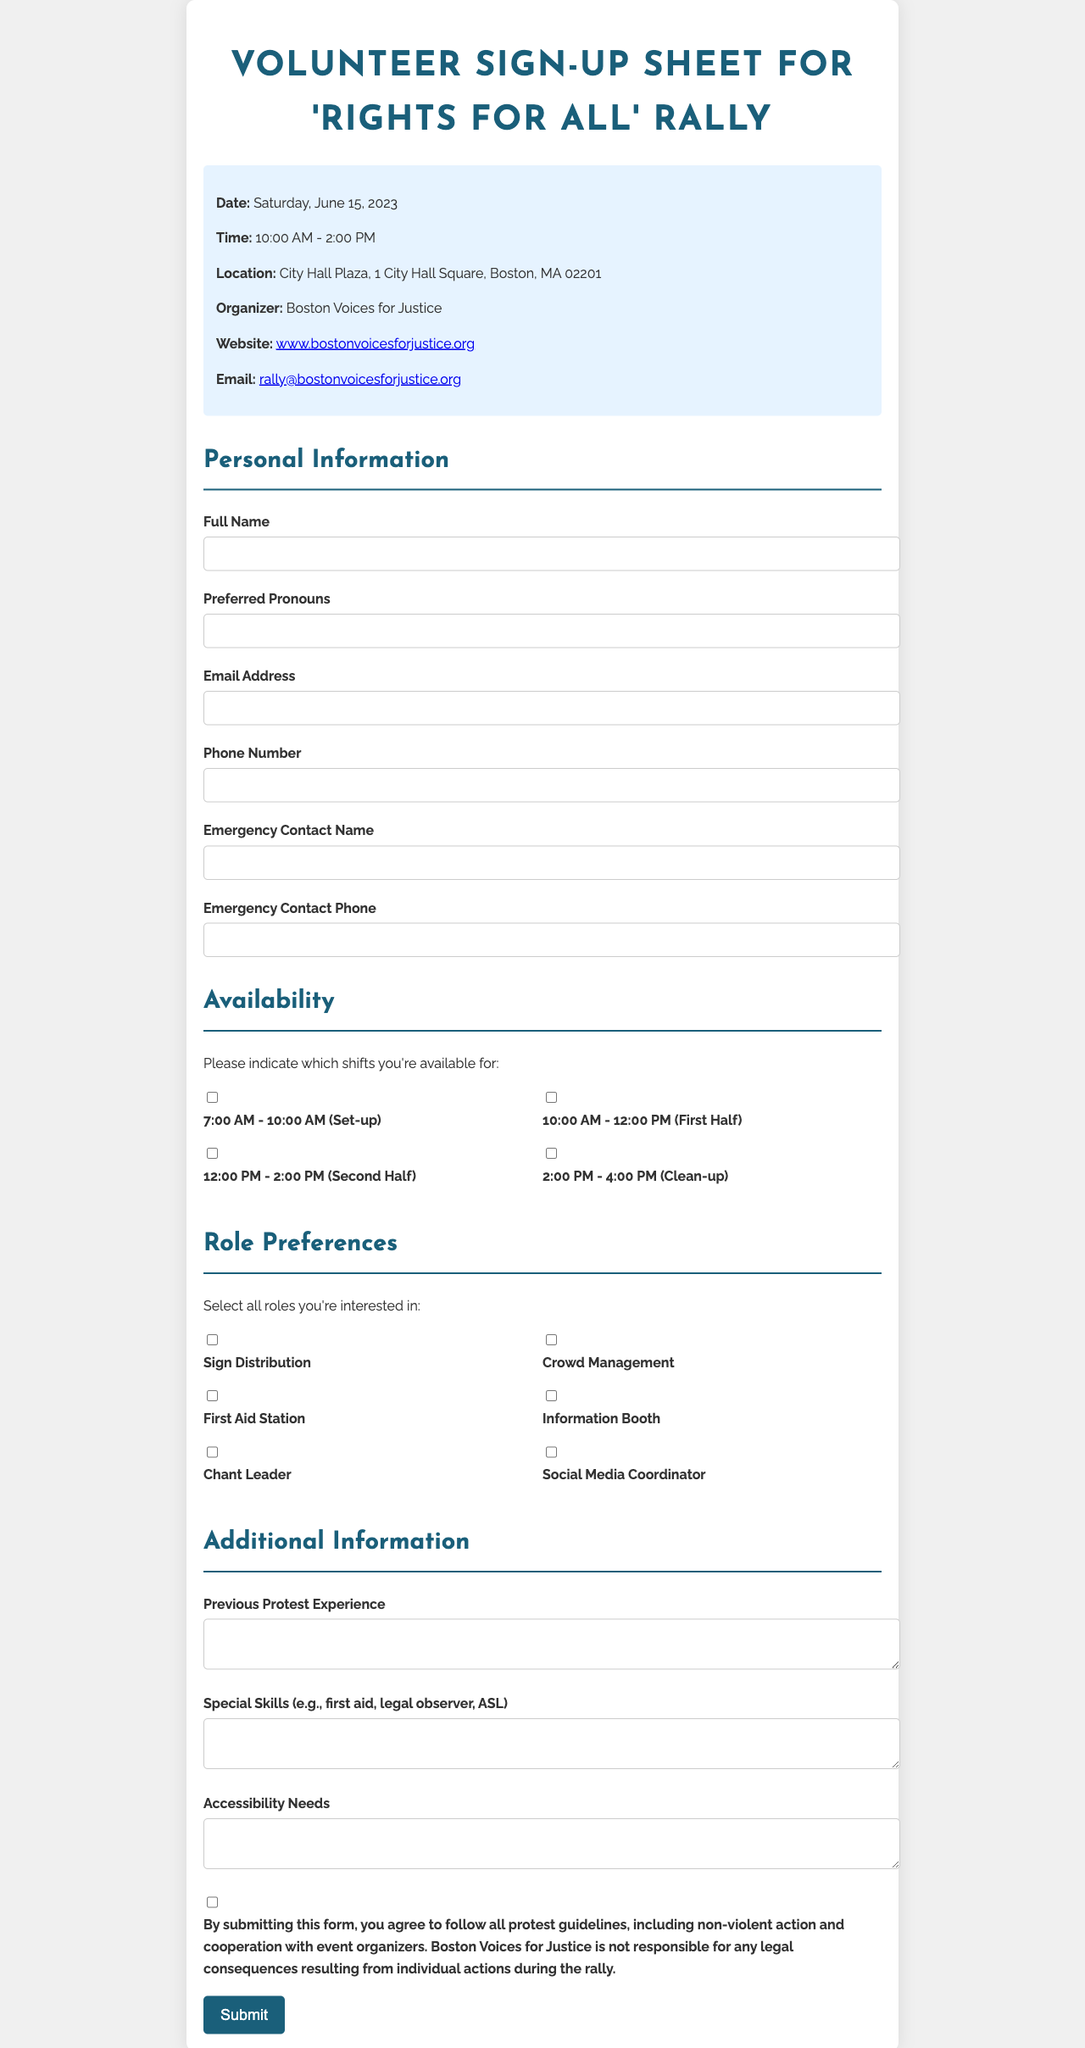what is the event date? The event date is stated in the document and is specifically mentioned as a single day.
Answer: Saturday, June 15, 2023 what time does the rally start? The rally's start time is clearly indicated in the event details section.
Answer: 10:00 AM where is the rally taking place? The location of the rally is explicitly stated in the document under event details.
Answer: City Hall Plaza, 1 City Hall Square, Boston, MA 02201 who is organizing the rally? The organizer's name is provided in the organizer information section of the document.
Answer: Boston Voices for Justice what role can a volunteer take on? The document lists various roles in the role preferences section that volunteers can select from.
Answer: Sign Distribution how many shifts are available for volunteering? The availability section lists the number of shifts described in the document.
Answer: Four shifts what must volunteers agree to by submitting the form? The legal disclaimer section explains what volunteers agree to when they submit the form.
Answer: Protest guidelines is the phone number of the organizer provided? The organizer information section contains contact details, specifically relating to their phone contact.
Answer: No what type of form is this? The form’s title indicates its purpose and the context of the event it is related to.
Answer: Volunteer Sign-Up Sheet 